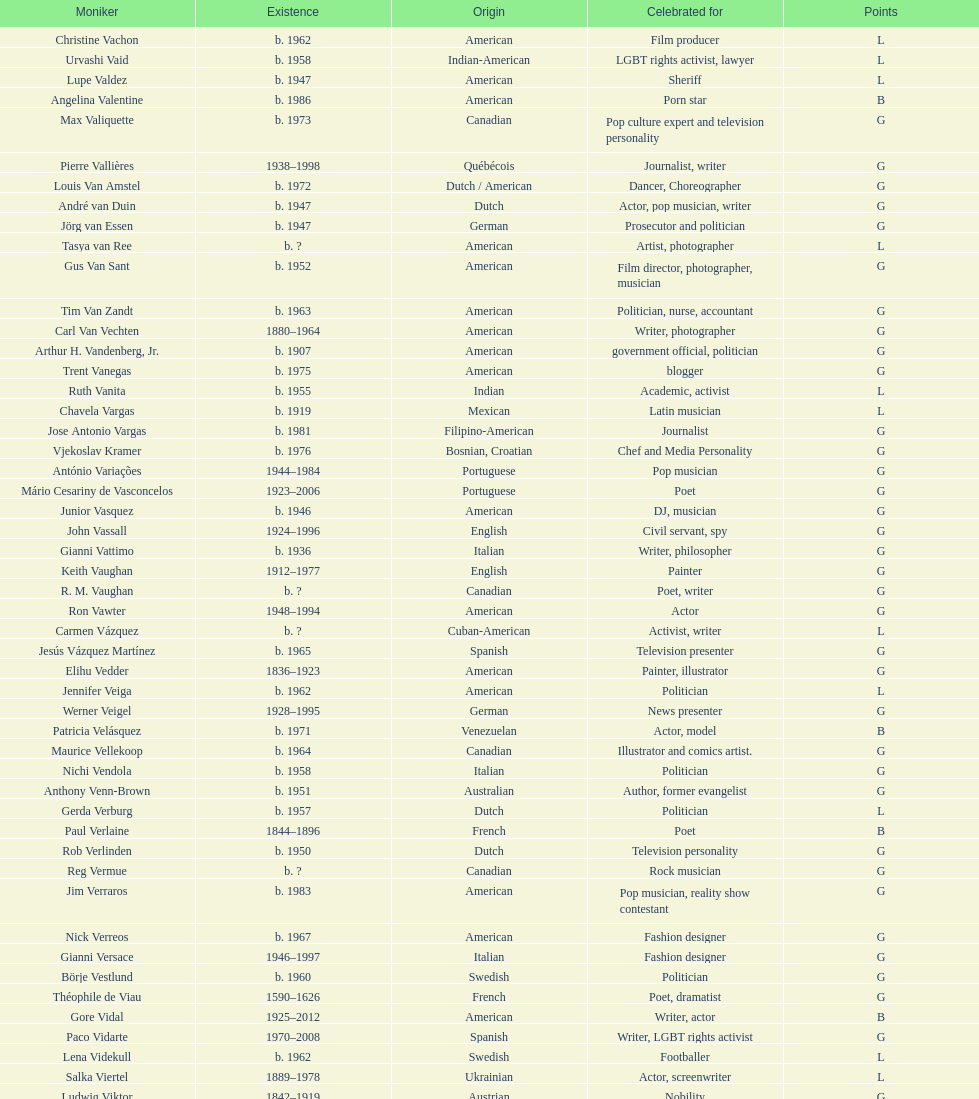Which nationality had the most notable poets? French. 